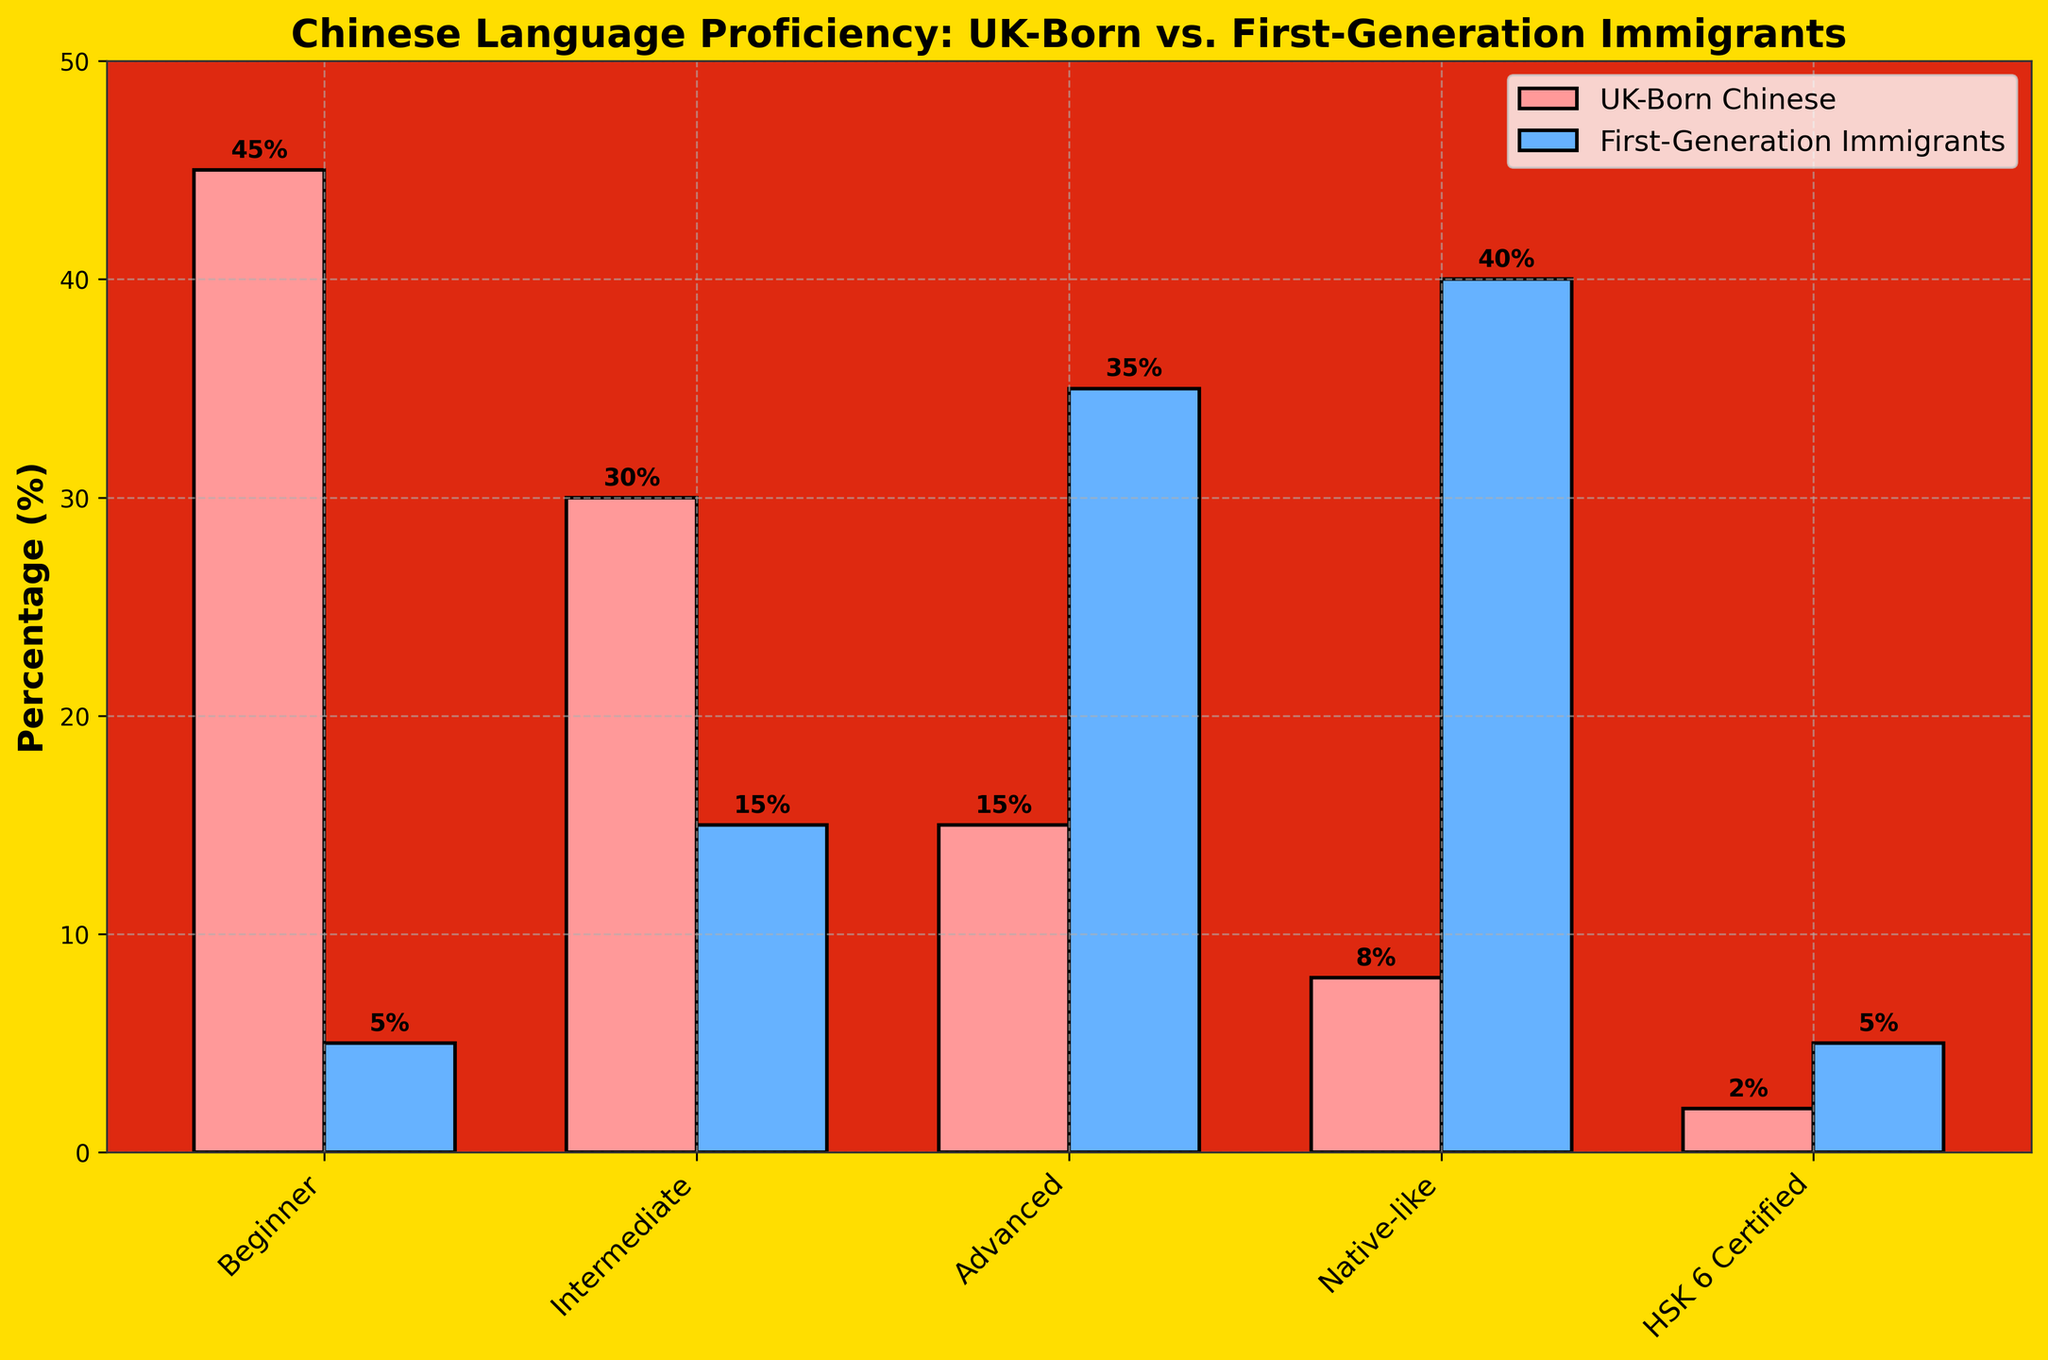What percentage of UK-born Chinese have a beginner level of Chinese language proficiency? The bar corresponding to Beginner for UK-born Chinese shows 45%.
Answer: 45% Which group has a higher percentage of individuals with an advanced level of proficiency, UK-born Chinese or first-generation immigrants, and by how much? The bar for Advanced proficiency shows 35% for first-generation immigrants and 15% for UK-born Chinese. The difference is 35 - 15 = 20%.
Answer: First-generation immigrants by 20% What is the combined percentage of UK-born Chinese who are at intermediate and advanced levels of proficiency? The percentage for Intermediate is 30%, and for Advanced it is 15%. Summing them up: 30 + 15 = 45%.
Answer: 45% Which language proficiency level has the smallest percentage difference between UK-born Chinese and first-generation immigrants, and what is the difference? Look at all proficiency levels and their differences:
- Beginner: 45 - 5 = 40%
- Intermediate: 30 - 15 = 15%
- Advanced: 35 - 15 = 20%
- Native-like: 40 - 8 = 32%
- HSK 6 Certified: 5 - 2 = 3%
The smallest difference is for HSK 6 Certified: 3%.
Answer: HSK 6 Certified, 3% What percentage of UK-born Chinese have a proficiency level of "Native-like" or higher (including HSK 6 Certified)? Native-like is 8% and HSK 6 Certified is 2%. Sum them up: 8 + 2 = 10%.
Answer: 10% Compare the visual lengths of the bars for the "Intermediate" level between UK-born Chinese and first-generation immigrants. Which group shows the taller bar? Visually comparing the lengths, the UK-born Chinese bar for Intermediate proficiency is taller.
Answer: UK-born Chinese What is the ratio of first-generation immigrants with a native-like level of Chinese proficiency to those with a beginner level? The percentage for Native-like is 40%, and for Beginner is 5%. The ratio is 40 / 5 = 8.
Answer: 8 How much more percentage of first-generation immigrants have an advanced or native-like proficiency compared to intermediate proficiency? For Advanced, it is 35%, and for Native-like, it is 40%. Combined, it is 35 + 40 = 75%. For Intermediate, it is 15%. The difference is 75 - 15 = 60%.
Answer: 60% Based on the visual attributes, which group generally shows higher proficiency levels in Chinese? The bars for higher proficiency levels (Advanced, Native-like, HSK 6 Certified) are taller for first-generation immigrants as compared to UK-born Chinese.
Answer: First-generation immigrants 